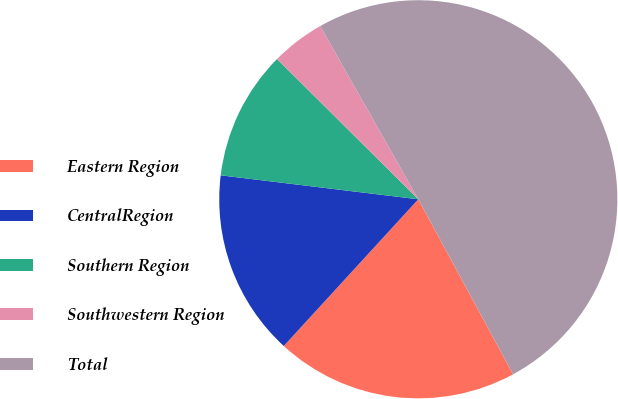<chart> <loc_0><loc_0><loc_500><loc_500><pie_chart><fcel>Eastern Region<fcel>CentralRegion<fcel>Southern Region<fcel>Southwestern Region<fcel>Total<nl><fcel>19.71%<fcel>15.11%<fcel>10.52%<fcel>4.36%<fcel>50.3%<nl></chart> 